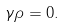<formula> <loc_0><loc_0><loc_500><loc_500>\gamma \rho = 0 .</formula> 